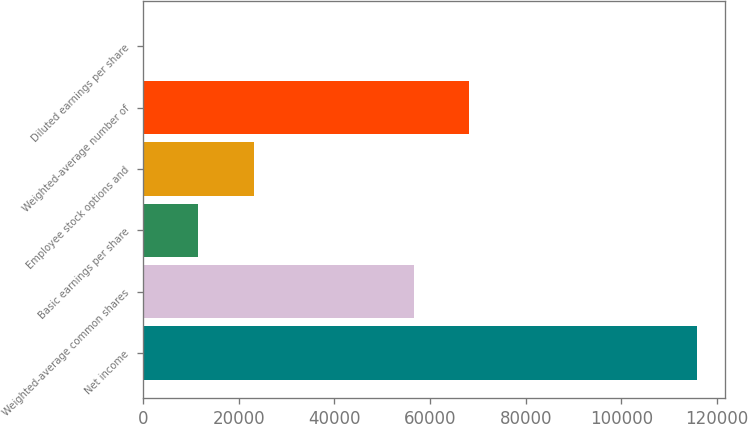Convert chart. <chart><loc_0><loc_0><loc_500><loc_500><bar_chart><fcel>Net income<fcel>Weighted-average common shares<fcel>Basic earnings per share<fcel>Employee stock options and<fcel>Weighted-average number of<fcel>Diluted earnings per share<nl><fcel>115860<fcel>56560<fcel>11587.8<fcel>23173.6<fcel>68145.8<fcel>1.98<nl></chart> 